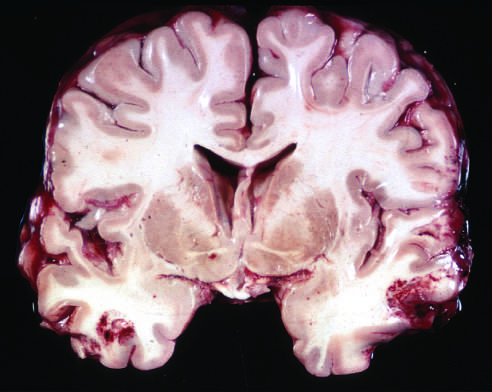where are the acute contusions present?
Answer the question using a single word or phrase. In both temporal lobes 